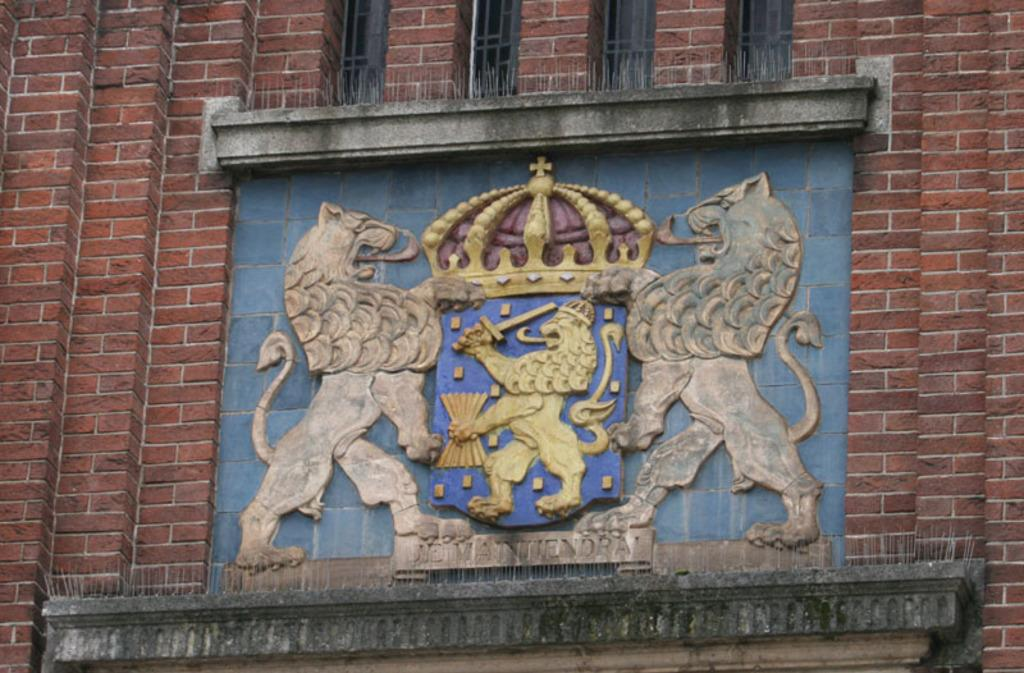What type of structure is visible in the image? There is a brick wall in the image. Can you describe any specific features of the wall? Yes, there is a carved design in the middle of the wall. What type of coat is the police officer wearing in the image? There are no police officers or coats present in the image; it only features a brick wall with a carved design. 